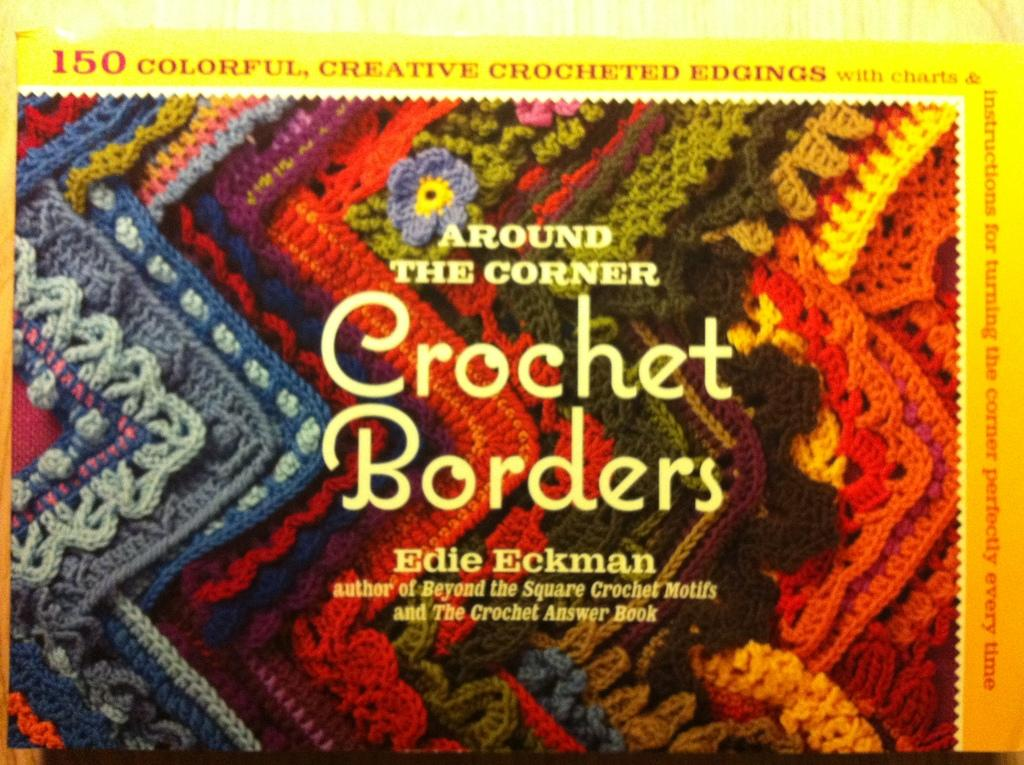<image>
Present a compact description of the photo's key features. The book cover to Around The Corner Crochet Borders by Edie Eckman. 